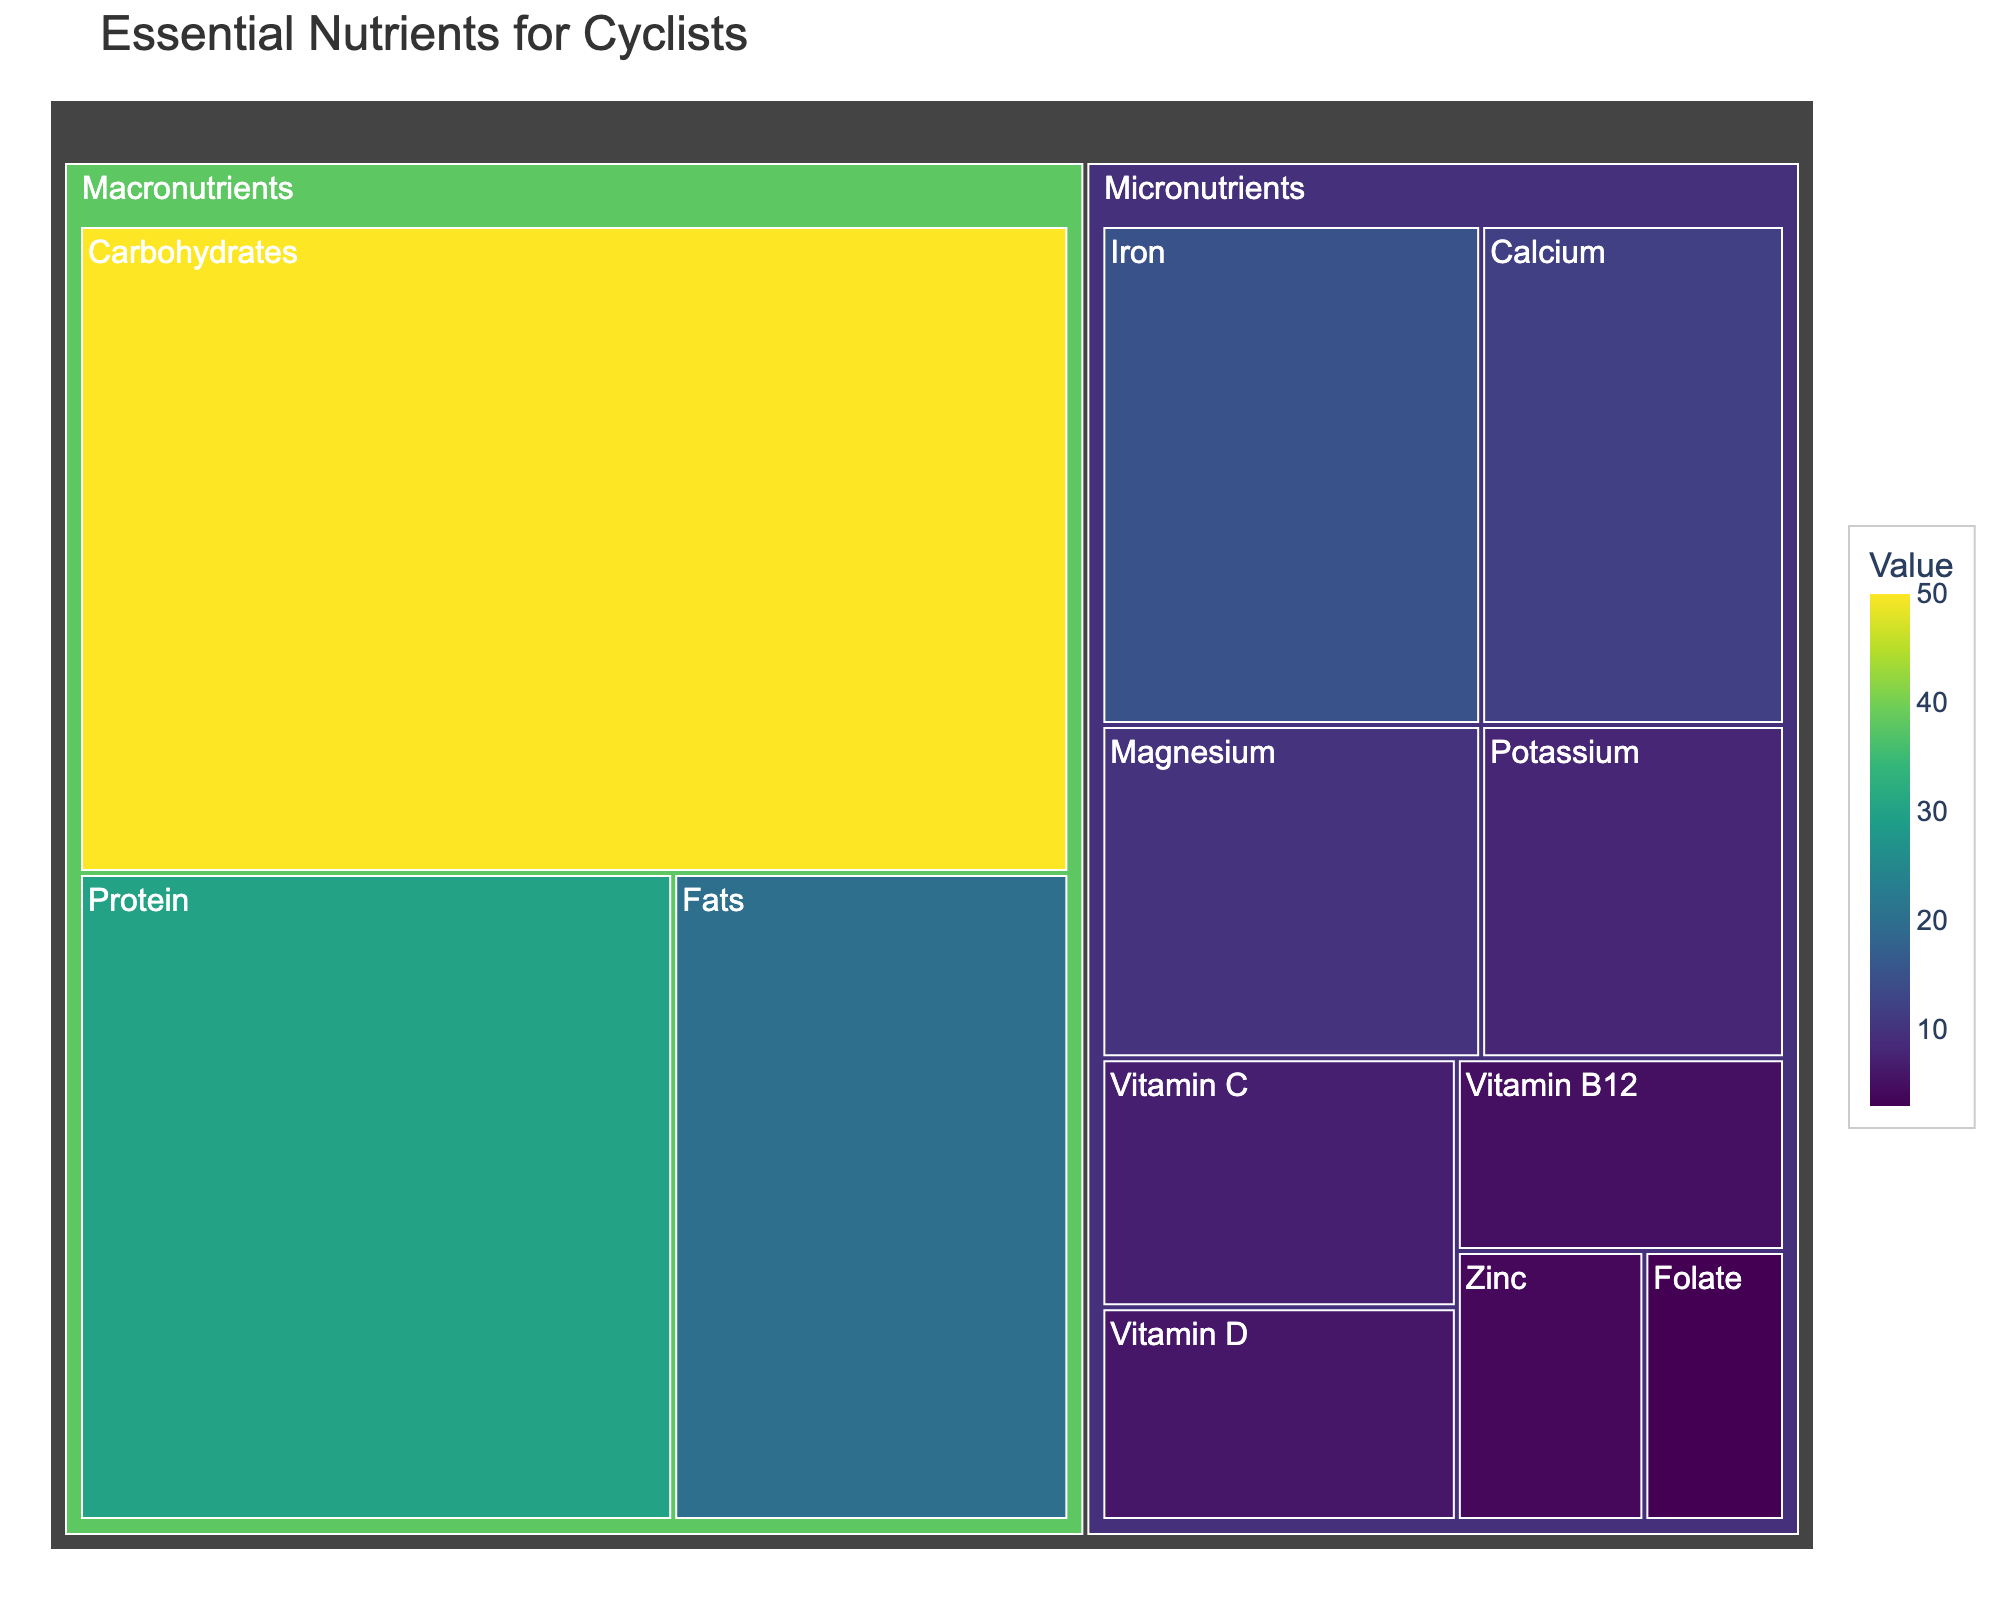What is the largest category in terms of value, macronutrients or micronutrients? By looking at the treemap, compare the sizes allocated to each category (macronutrients and micronutrients). The macronutrients category is visibly larger.
Answer: Macronutrients How much more carbohydrate value is there compared to protein? Find the values for carbohydrates (50) and protein (30) from the treemap. Subtract the protein value from the carbohydrate value (50 - 30).
Answer: 20 Which subcategory within the micronutrients has the smallest value? Identify the smallest value within the subcategories listed under micronutrients. Folate has the value of 3, which is the smallest.
Answer: Folate What is the combined value of iron and calcium? Locate the values for iron (15) and calcium (12) from the treemap. Add these values together (15 + 12).
Answer: 27 How does the value of fats compare to the value of potassium? Locate the values for fats (20) and potassium (8). Compare these values directly.
Answer: Fats have a higher value than potassium What percentage of the total micronutrient value does iron represent? Sum all the micronutrient values: 15 (Iron) + 12 (Calcium) + 10 (Magnesium) + 8 (Potassium) + 7 (Vitamin C) + 6 (Vitamin D) + 5 (Vitamin B12) + 4 (Zinc) + 3 (Folate) = 70. Then, calculate the percentage for iron: (15 / 70) * 100%.
Answer: 21.43% Which category shows more diversity in subcategories, macronutrients or micronutrients? Count the number of subcategories within each major category. Macronutrients have 3 subcategories, while micronutrients have 10.
Answer: Micronutrients How does the value of vitamin B12 compare to the value of magnesium? Find the values of vitamin B12 (5) and magnesium (10). Compare these values directly.
Answer: Magnesium has a higher value than vitamin B12 What is the total value for all the subcategories related to vitamins in the micronutrients? Identify and sum the values of vitamin-related subcategories: 7 (Vitamin C) + 6 (Vitamin D) + 5 (Vitamin B12) = 18.
Answer: 18 If you combine the values of protein and fats, what percentage do they represent of the total macronutrient value? First, find the combined value of protein (30) and fats (20), which equals 50. The total macronutrient value is 50 (Carbohydrates) + 30 (Protein) + 20 (Fats) = 100. Then, calculate the percentage: (50 / 100) * 100%.
Answer: 50% 